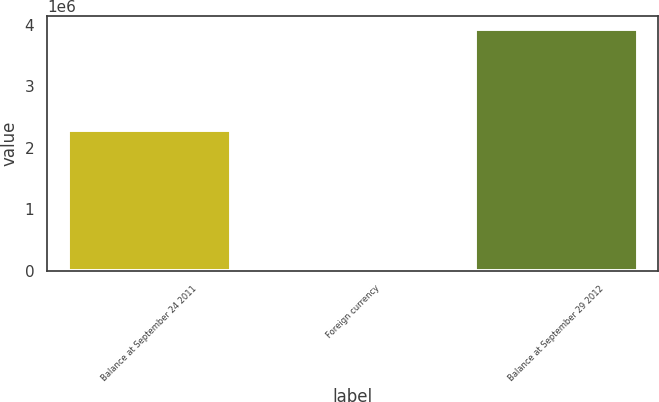Convert chart. <chart><loc_0><loc_0><loc_500><loc_500><bar_chart><fcel>Balance at September 24 2011<fcel>Foreign currency<fcel>Balance at September 29 2012<nl><fcel>2.29033e+06<fcel>3288<fcel>3.94278e+06<nl></chart> 